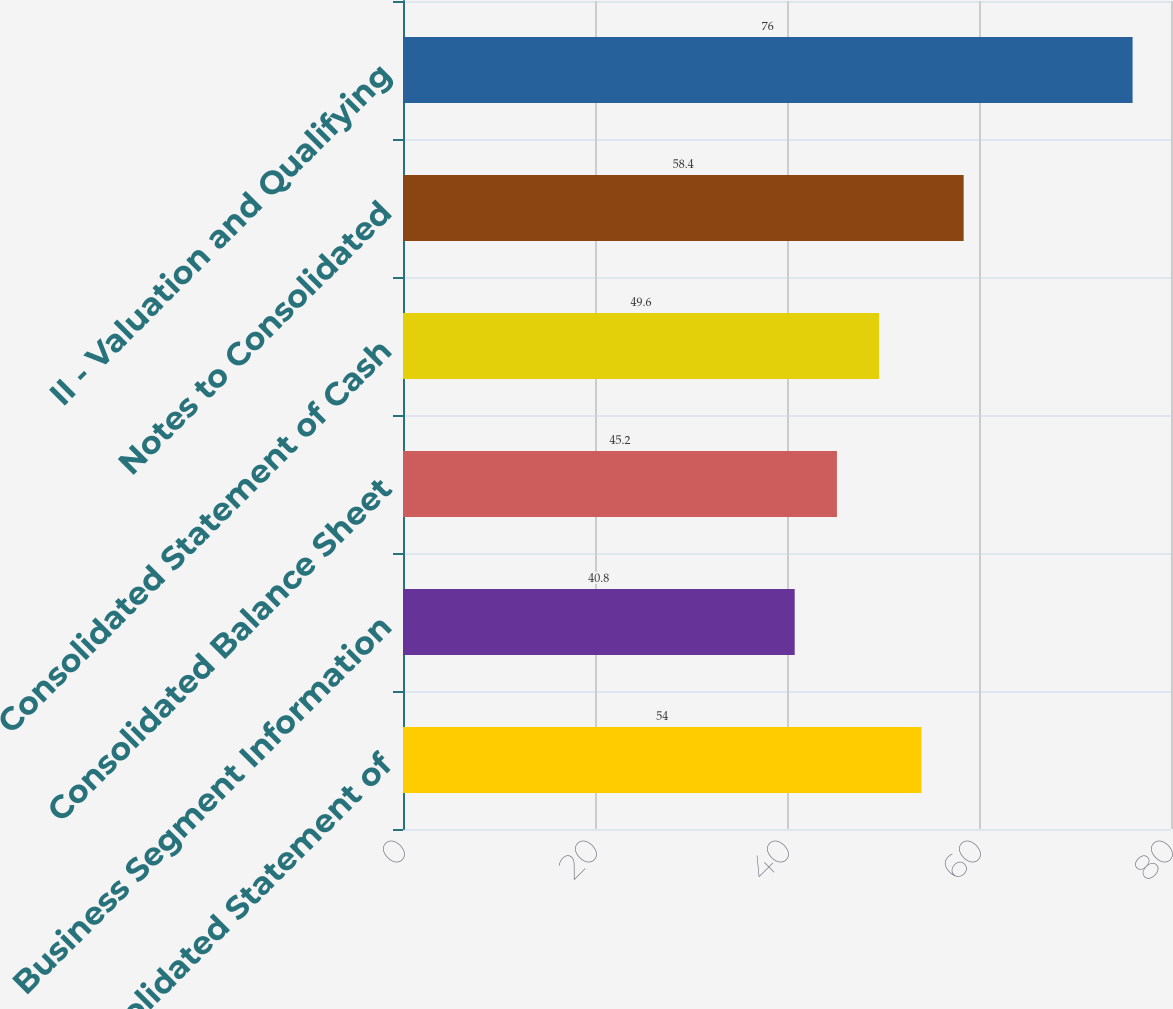Convert chart. <chart><loc_0><loc_0><loc_500><loc_500><bar_chart><fcel>Consolidated Statement of<fcel>Business Segment Information<fcel>Consolidated Balance Sheet<fcel>Consolidated Statement of Cash<fcel>Notes to Consolidated<fcel>II - Valuation and Qualifying<nl><fcel>54<fcel>40.8<fcel>45.2<fcel>49.6<fcel>58.4<fcel>76<nl></chart> 